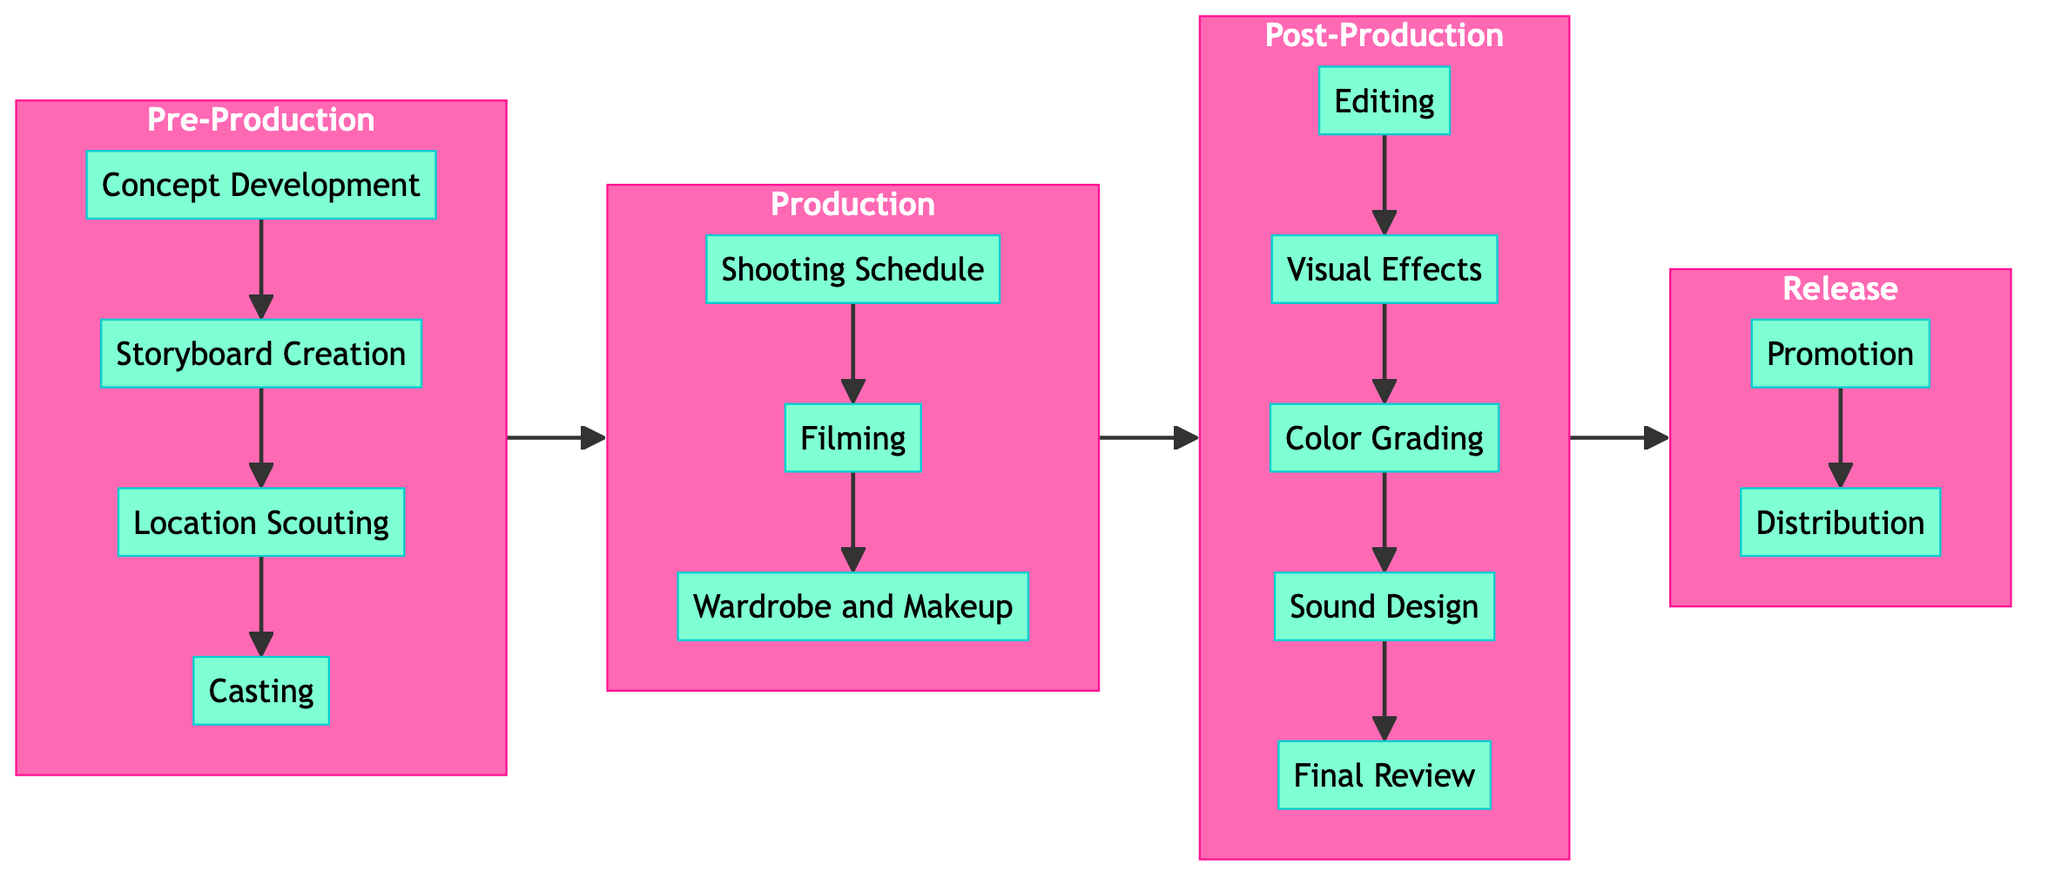What is the first element in the Pre-Production stage? The first element in the Pre-Production stage is reached directly from the stage node and listed sequentially, which is Concept Development.
Answer: Concept Development How many elements are in the Post-Production stage? By counting the listed elements within the Post-Production subgraph, there are five distinct elements: Editing, Visual Effects, Color Grading, Sound Design, and Final Review.
Answer: Five What is the last element before the Release stage? Tracing the flow from the Post-Production stage to the Release stage reveals that Final Review is the last element before advancing to Promotion.
Answer: Final Review Which team role is involved in both Filming and Final Review? Analyzing the resources associated with both Filming and Final Review identifies the Director as the common team role involved in both parts of the workflow.
Answer: Director How does casting relate to storyboard creation? Casting follows after the Storyboard Creation in the Pre-Production stage; thus, it is determined that casting is a subsequent step following storyboard development in the workflow.
Answer: Subsequent What are the elements between Production and Post-Production? The connection from Production to Post-Production involves Filming transitioning to Editing, followed by Visual Effects, Color Grading, and Sound Design. Therefore, the elements in that transition are Filming, Editing, Visual Effects, Color Grading, and Sound Design.
Answer: Filming, Editing, Visual Effects, Color Grading, Sound Design Which stage has the fewest elements? By reviewing the elements in each stage, the Release stage has the fewest, containing only two elements: Promotion and Distribution, when compared to the others.
Answer: Release In which stage does sound design occur? Sound Design is linked to the Post-Production stage, specifically as the fourth step, showing its placement in the overall workflow.
Answer: Post-Production 